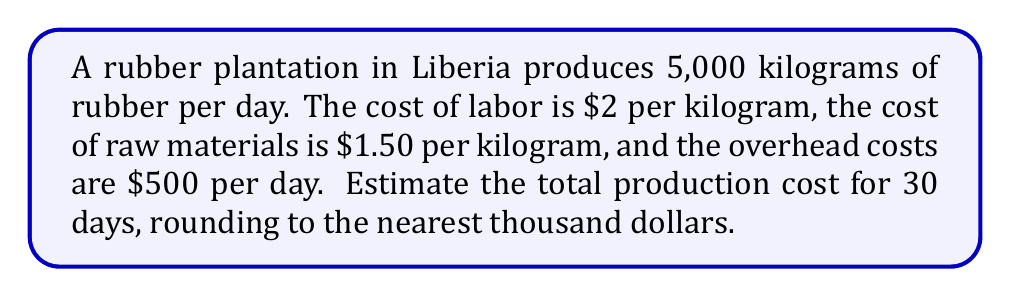Give your solution to this math problem. Let's break this problem down into steps:

1. Calculate the daily cost of labor:
   $$ \text{Daily labor cost} = 5,000 \text{ kg} \times \$2/\text{kg} = \$10,000 $$

2. Calculate the daily cost of raw materials:
   $$ \text{Daily material cost} = 5,000 \text{ kg} \times \$1.50/\text{kg} = \$7,500 $$

3. Add the daily overhead cost:
   $$ \text{Total daily cost} = \$10,000 + \$7,500 + \$500 = \$18,000 $$

4. Calculate the total cost for 30 days:
   $$ \text{30-day cost} = \$18,000 \times 30 = \$540,000 $$

5. Round to the nearest thousand dollars:
   $\$540,000$ rounds to $\$540,000$

Therefore, the estimated production cost for 30 days is $\$540,000$.
Answer: $540,000 